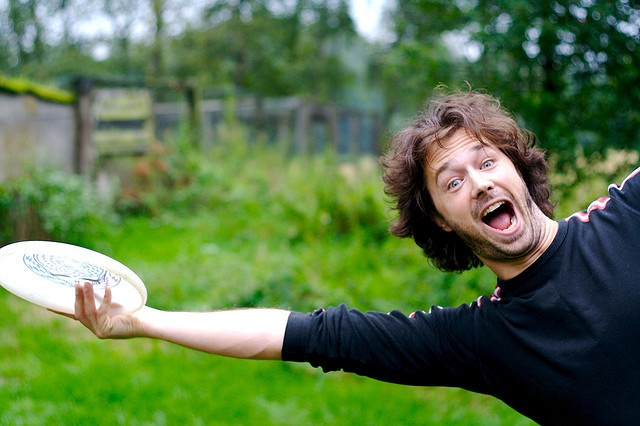Describe the objects in this image and their specific colors. I can see people in lightblue, black, white, navy, and gray tones and frisbee in lightblue, white, and darkgray tones in this image. 